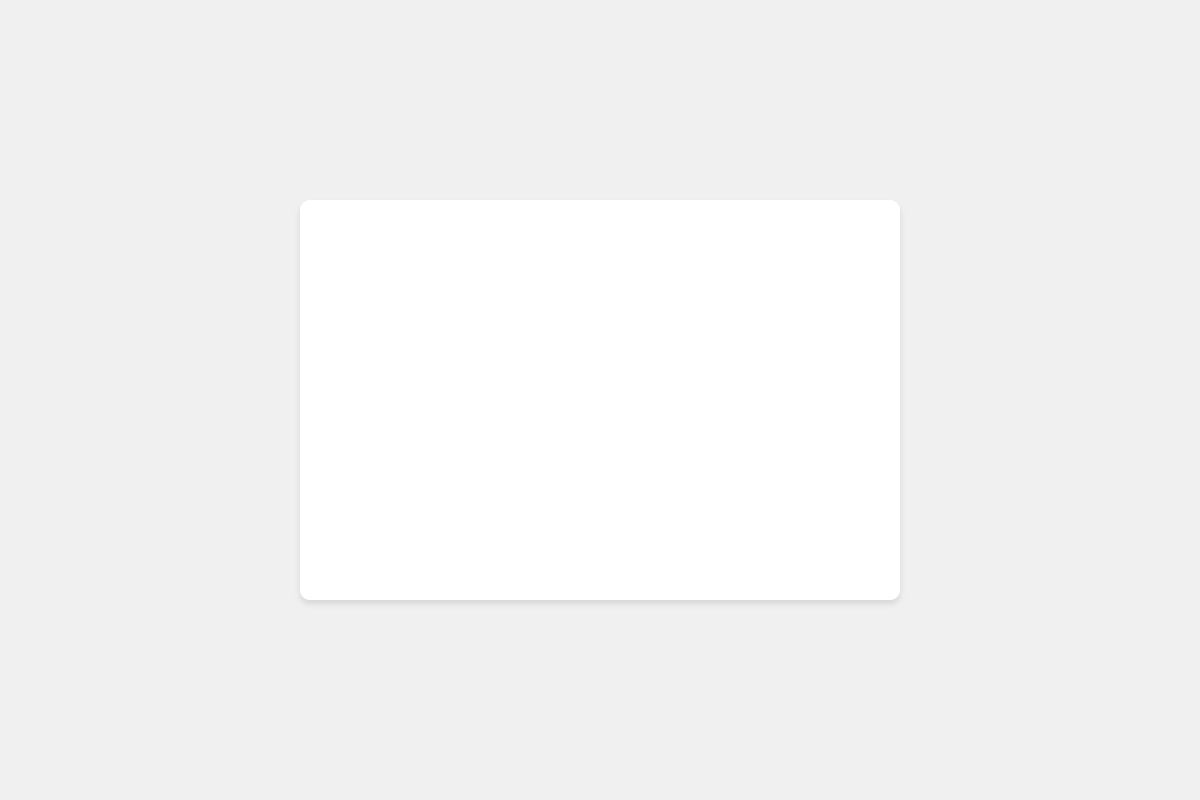Which category has a higher value: IDE or Text Editor? The pie chart shows the percentages of the IDE and Text Editor categories. The IDE section occupies 65% of the pie, while Text Editor occupies 35%.
Answer: IDE What is the difference in percentage between the IDE and Text Editor categories? The percentage of IDE is 65%, and the percentage of Text Editor is 35%. The difference is calculated as 65% - 35%.
Answer: 30% What is the combined percentage of both categories? Since the chart represents the total distribution of the two categories, their combined percentage is the sum of their individual percentages: 65% (IDE) + 35% (Text Editor).
Answer: 100% Which color represents the Text Editor category? In the pie chart, the section representing the Text Editor category is marked in blue.
Answer: Blue What is the ratio of IDE to Text Editor values? IDE has a value of 65 and Text Editor has a value of 35. The ratio is calculated by dividing the value of IDE by the value of Text Editor: 65 / 35.
Answer: 1.86 If the total number of participants is 100, how many prefer using IDEs? The percentage of participants who prefer using IDEs is 65%. If the total number of participants is 100, the number of participants preferring IDEs is 65% of 100.
Answer: 65 How many entities are associated with the IDE category? The entities listed for the IDE category are: Visual Studio Code, IntelliJ IDEA, PyCharm, Eclipse, and NetBeans. Counting these entities, we get 5.
Answer: 5 If there are 200 people surveyed, how many prefer Text Editors? The percentage of people preferring Text Editors is 35%. For 200 people, the number preferring Text Editors is 35% of 200. Calculation: 200 * 0.35.
Answer: 70 Which segment of the pie chart is larger, and by what visual attribute can you tell? The IDE segment is larger, which is evident by its greater proportion in the pie chart compared to the Text Editor segment.
Answer: IDE What logical conclusion can be drawn about the preference trends for development environments? The pie chart indicates that a larger proportion (65%) of participants prefer using IDEs over Text Editors (35%). This suggests a trend towards a higher preference for integrated development environments among the participants.
Answer: Higher preference for IDEs 